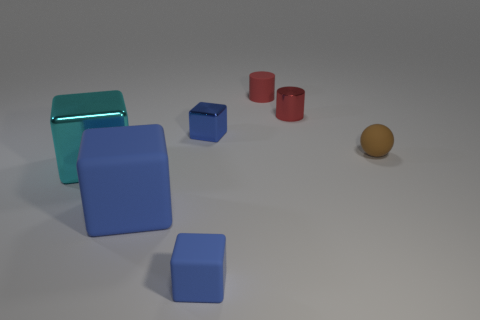What color is the block behind the tiny ball?
Ensure brevity in your answer.  Blue. Do the brown sphere and the metal cube that is on the left side of the big blue matte block have the same size?
Make the answer very short. No. There is a blue thing that is in front of the blue metallic block and right of the large blue matte block; what size is it?
Provide a short and direct response. Small. Are there any red cylinders made of the same material as the large cyan cube?
Provide a succinct answer. Yes. What is the shape of the brown object?
Provide a succinct answer. Sphere. Is the size of the cyan shiny object the same as the blue metal thing?
Give a very brief answer. No. What number of other objects are the same shape as the cyan thing?
Offer a very short reply. 3. What shape is the big object that is to the left of the big blue rubber cube?
Offer a very short reply. Cube. Do the small metallic object in front of the metal cylinder and the tiny rubber object that is on the left side of the tiny matte cylinder have the same shape?
Give a very brief answer. Yes. Are there the same number of brown spheres that are on the left side of the cyan object and large spheres?
Offer a very short reply. Yes. 